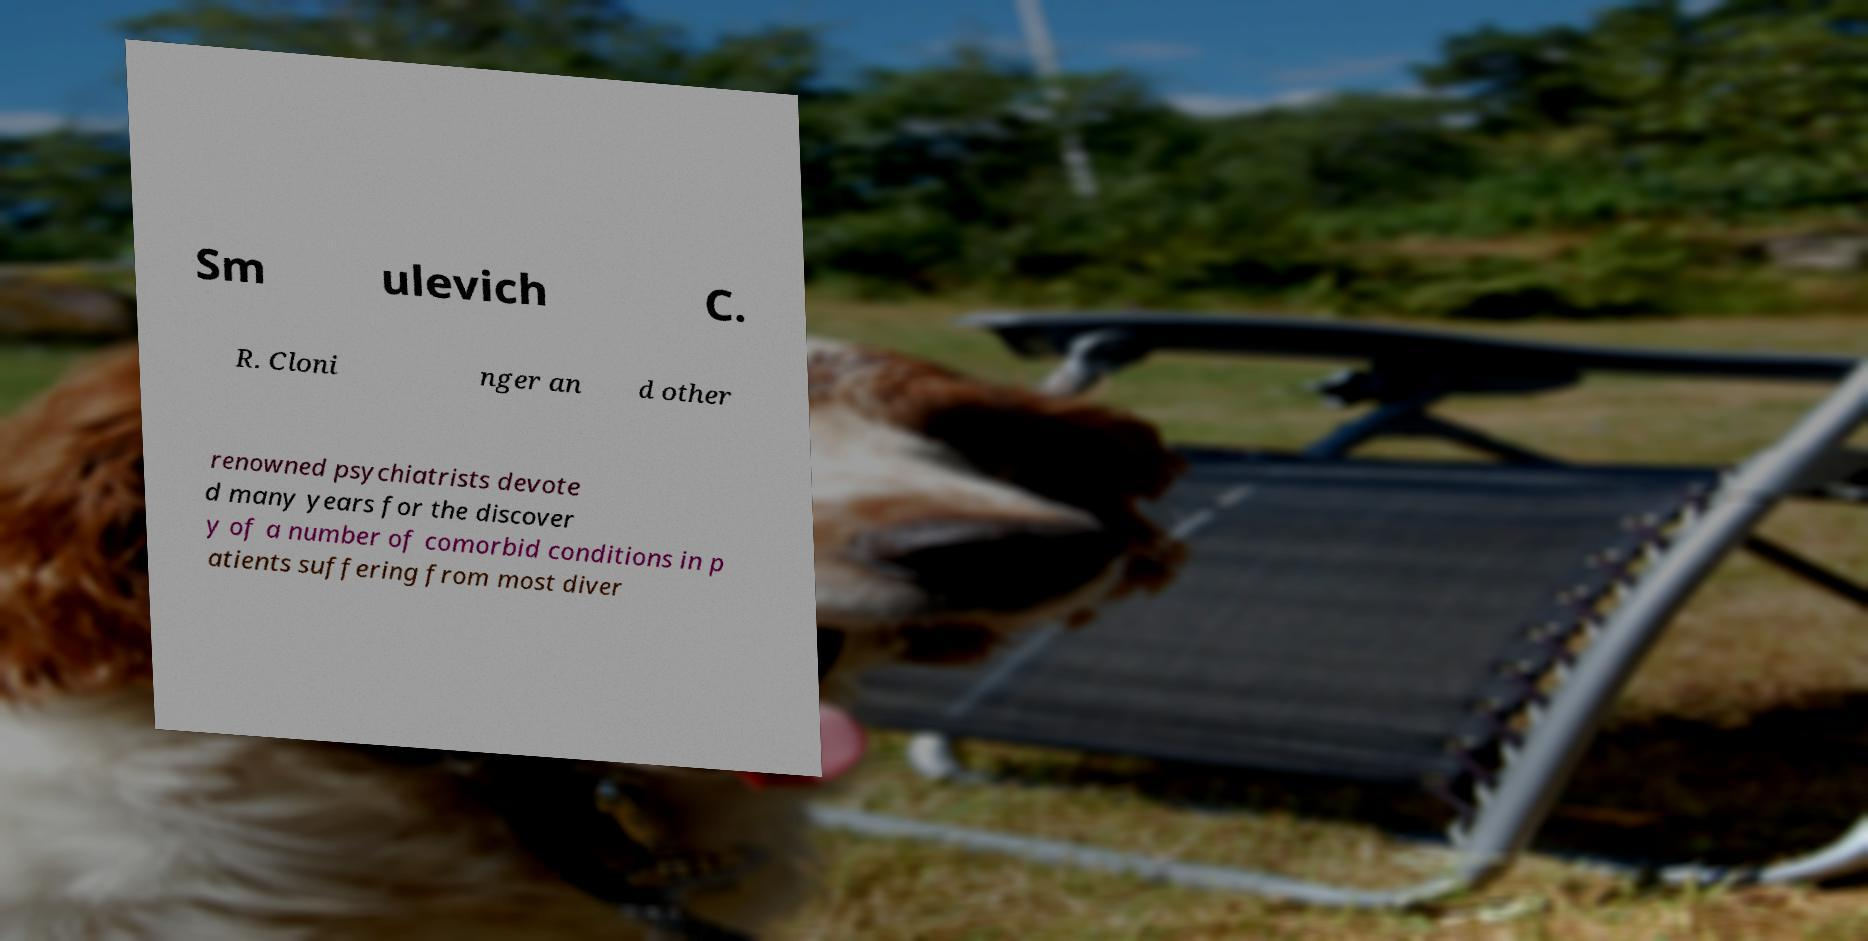What messages or text are displayed in this image? I need them in a readable, typed format. Sm ulevich C. R. Cloni nger an d other renowned psychiatrists devote d many years for the discover y of a number of comorbid conditions in p atients suffering from most diver 